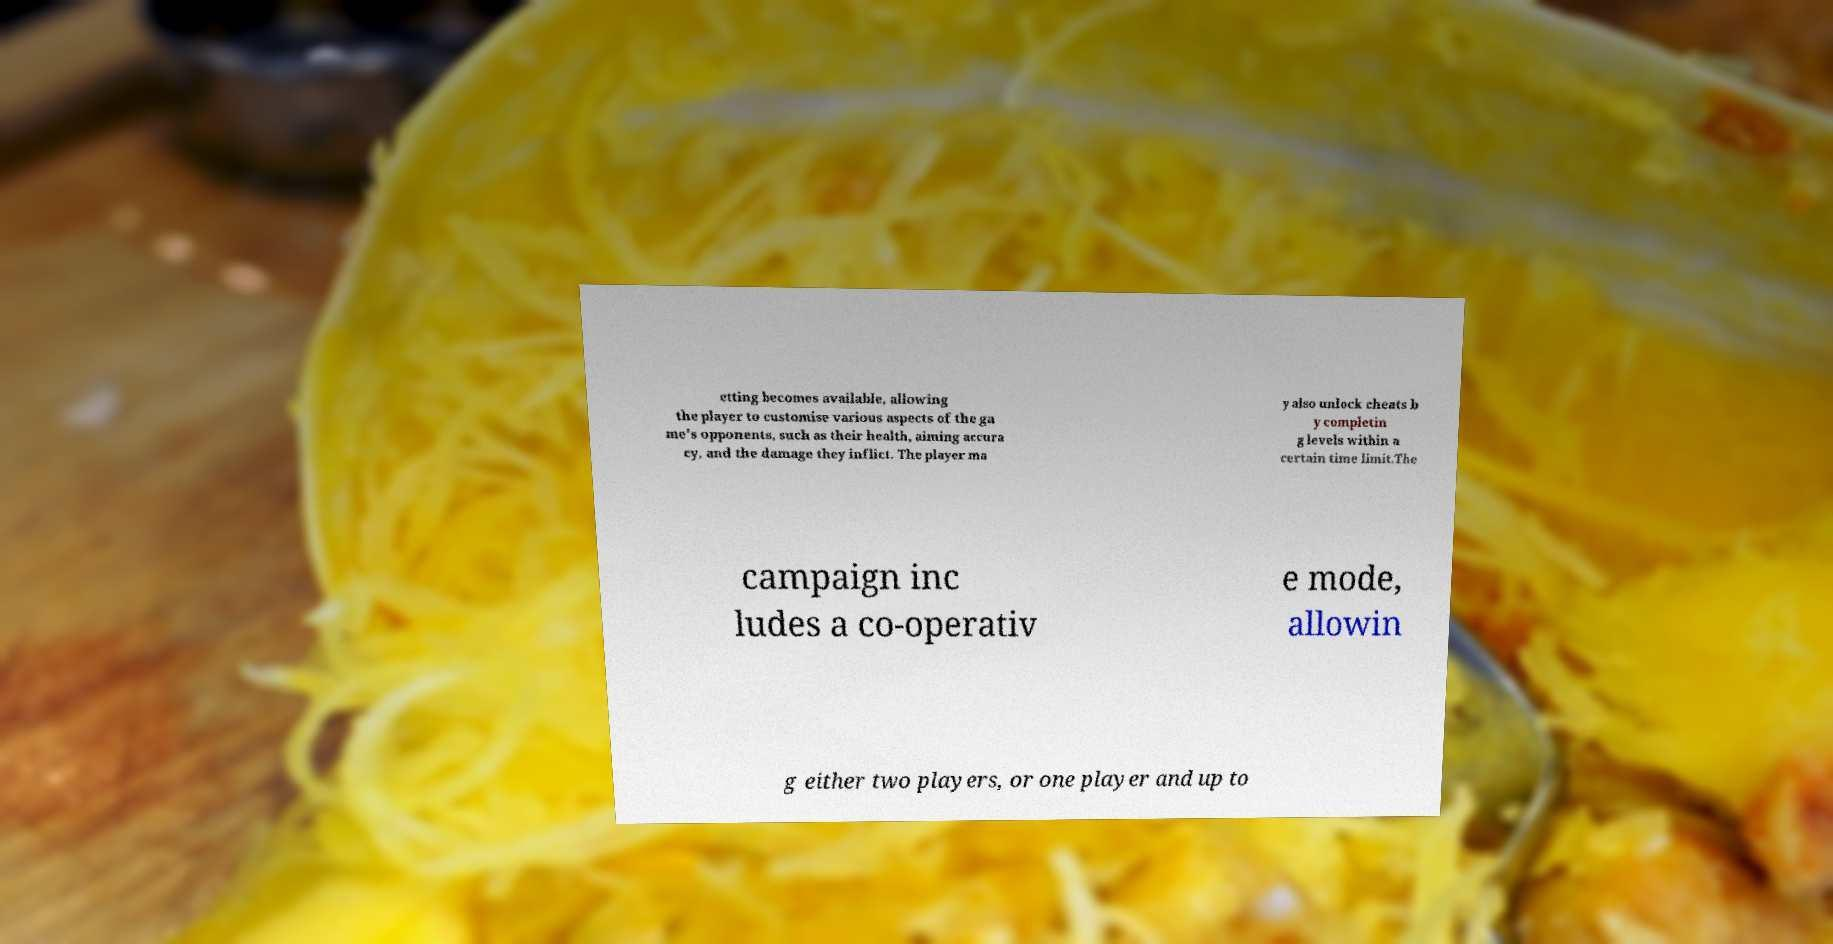I need the written content from this picture converted into text. Can you do that? etting becomes available, allowing the player to customise various aspects of the ga me's opponents, such as their health, aiming accura cy, and the damage they inflict. The player ma y also unlock cheats b y completin g levels within a certain time limit.The campaign inc ludes a co-operativ e mode, allowin g either two players, or one player and up to 